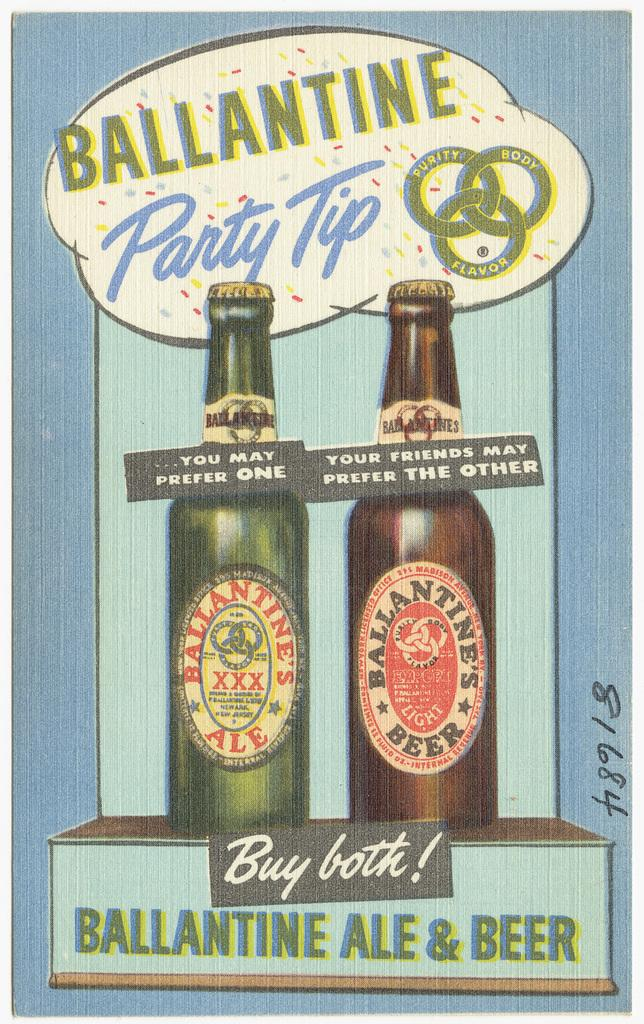<image>
Share a concise interpretation of the image provided. The advertisement recommends you buy both the ale and beer advertised. 